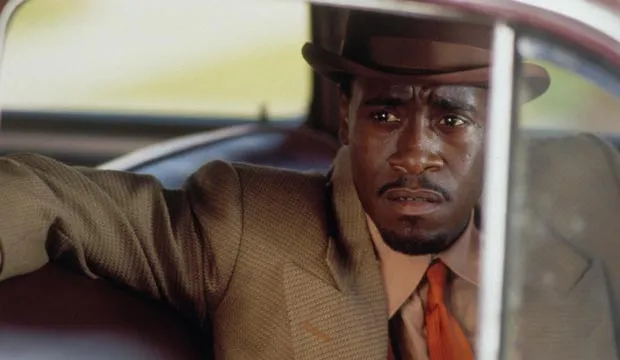Describe a casual conversation this detective might have. Detective: Hey there, Bill. Nice weather today, isn't it?
Bill: Sure is, Detective. Rare to see you without a case weighing you down.
Detective: Haha, well, it's a rare day off. Thought I'd take a moment to enjoy the simpler things. How's the family?
Bill: They're good, thanks for asking. Kids are growing up fast.
Detective: That's good to hear. Gotta cherish these moments. Before you know it, they’ll be all grown up and out in the world.
Bill: Ain't that the truth. Say, if you ever need a break from the city grind, you should come over for dinner sometime. The wife makes a mean roast.
Detective: I just might take you up on that, Bill. Thanks. 